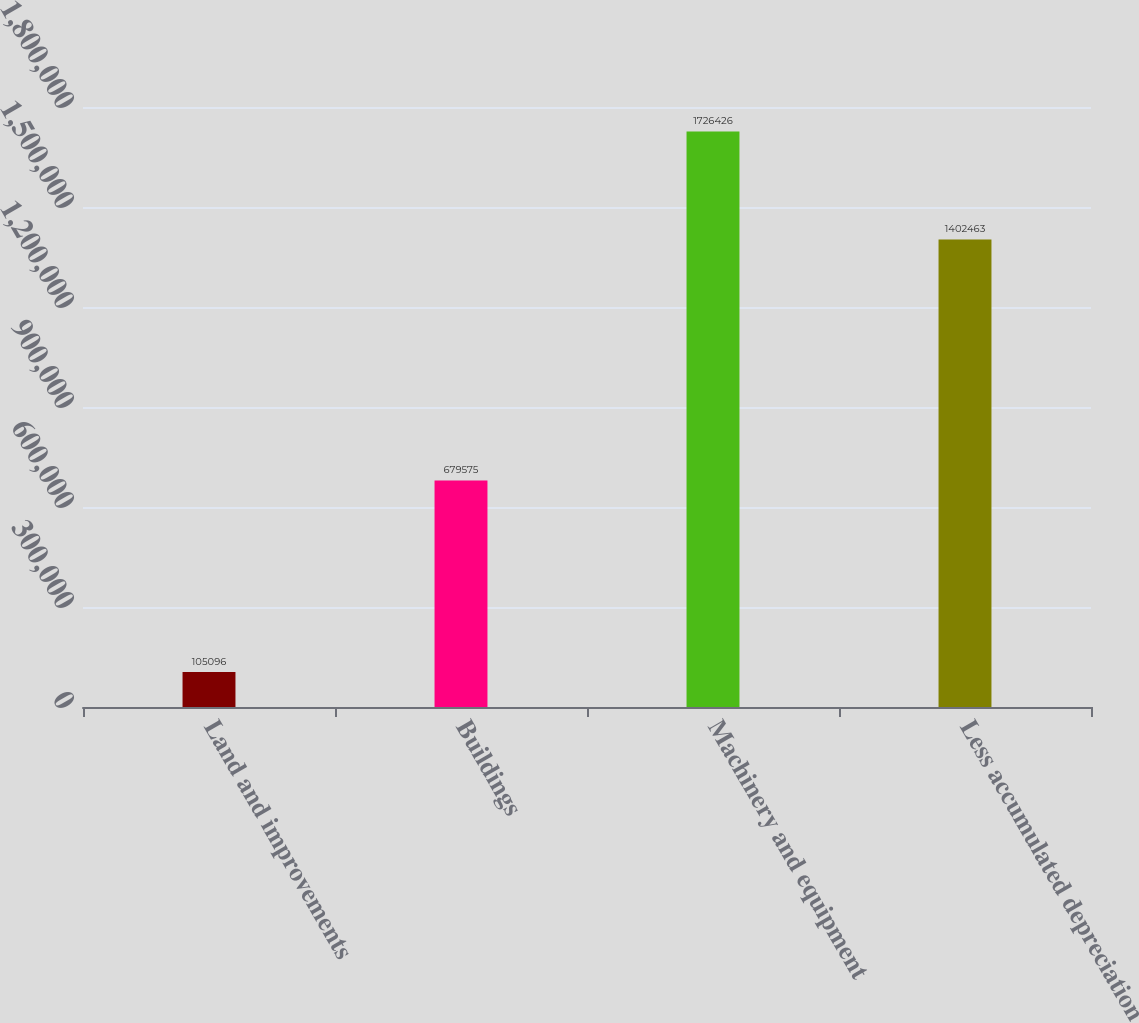Convert chart. <chart><loc_0><loc_0><loc_500><loc_500><bar_chart><fcel>Land and improvements<fcel>Buildings<fcel>Machinery and equipment<fcel>Less accumulated depreciation<nl><fcel>105096<fcel>679575<fcel>1.72643e+06<fcel>1.40246e+06<nl></chart> 